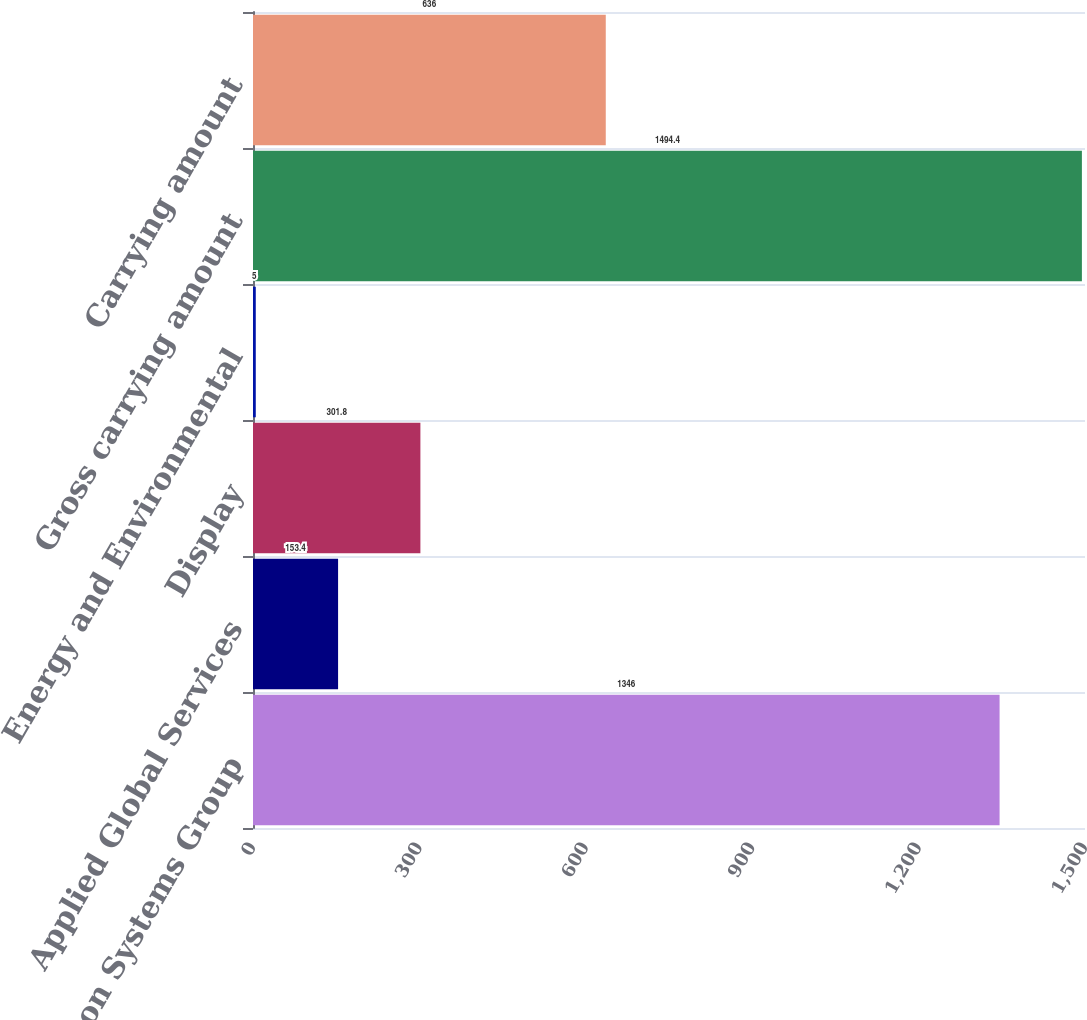Convert chart to OTSL. <chart><loc_0><loc_0><loc_500><loc_500><bar_chart><fcel>Silicon Systems Group<fcel>Applied Global Services<fcel>Display<fcel>Energy and Environmental<fcel>Gross carrying amount<fcel>Carrying amount<nl><fcel>1346<fcel>153.4<fcel>301.8<fcel>5<fcel>1494.4<fcel>636<nl></chart> 